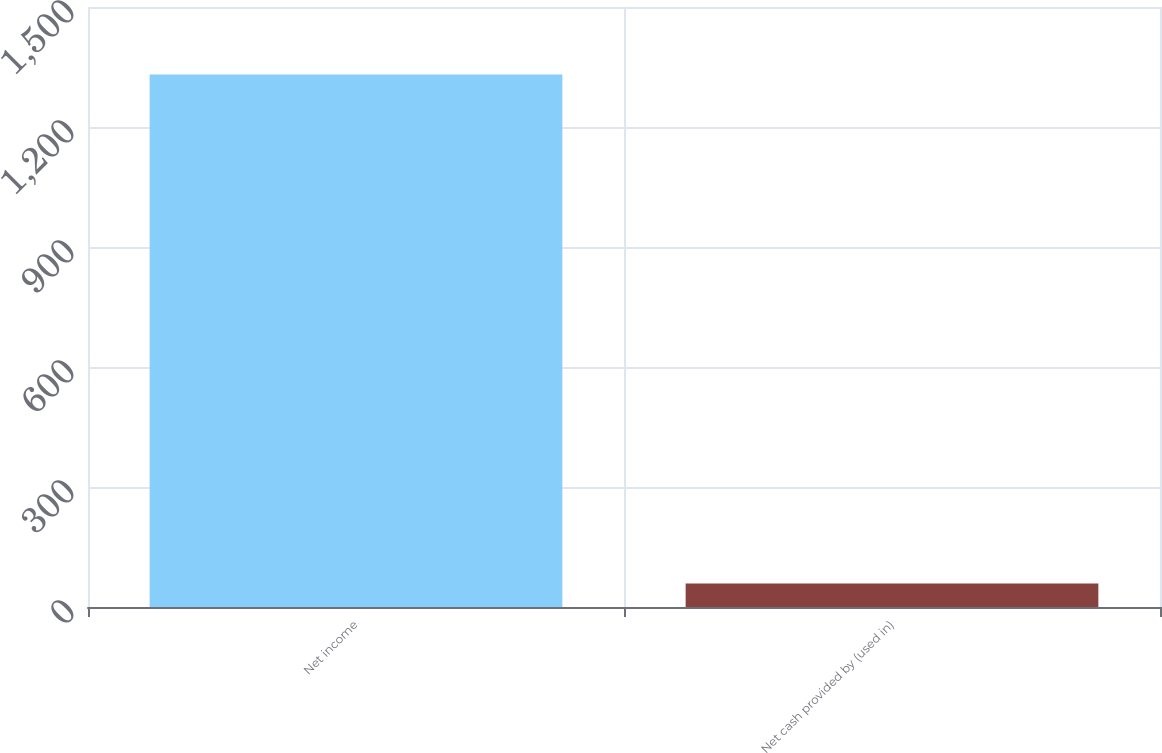Convert chart to OTSL. <chart><loc_0><loc_0><loc_500><loc_500><bar_chart><fcel>Net income<fcel>Net cash provided by (used in)<nl><fcel>1331<fcel>59<nl></chart> 